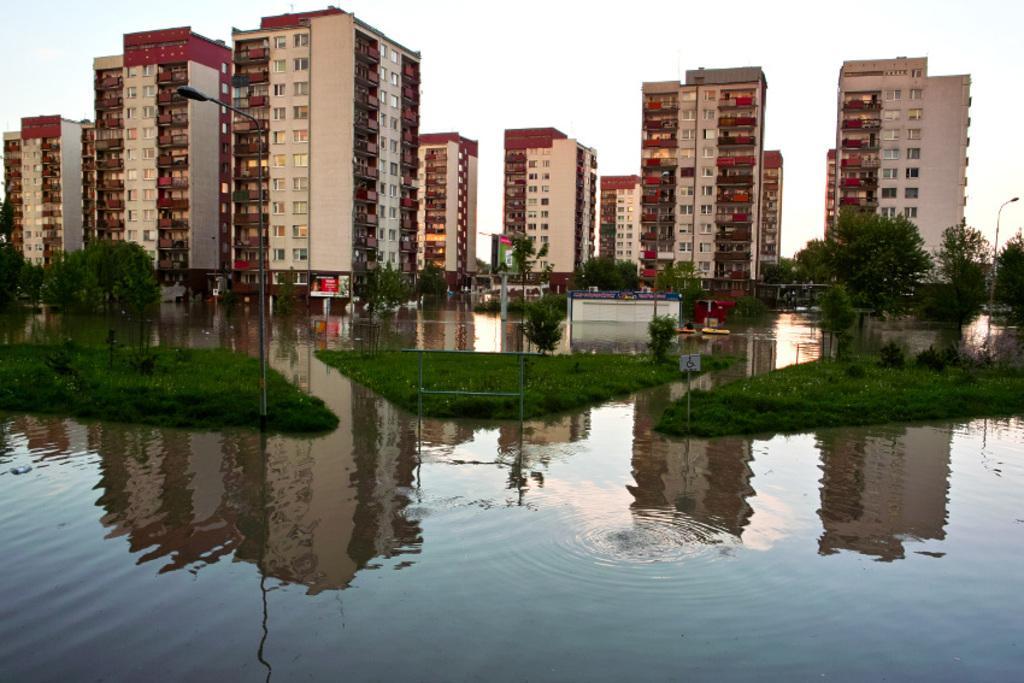Can you describe this image briefly? In this image we can see a group of buildings with windows. We can also see some boards, a group of trees, grass, street poles, the water and the sky which looks cloudy. 